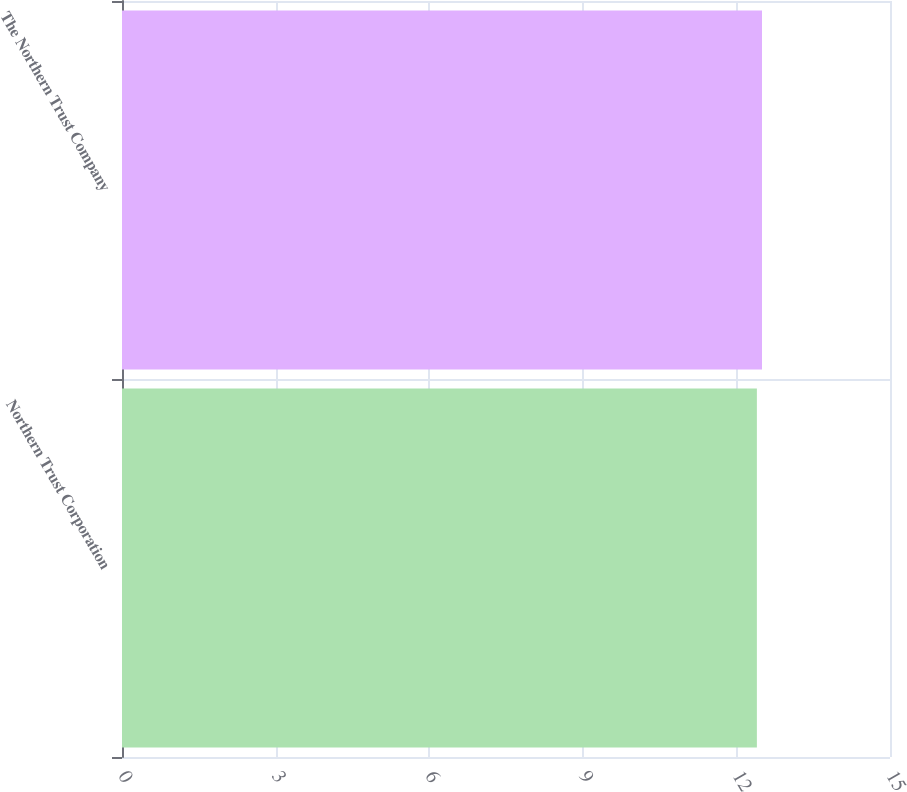<chart> <loc_0><loc_0><loc_500><loc_500><bar_chart><fcel>Northern Trust Corporation<fcel>The Northern Trust Company<nl><fcel>12.4<fcel>12.5<nl></chart> 